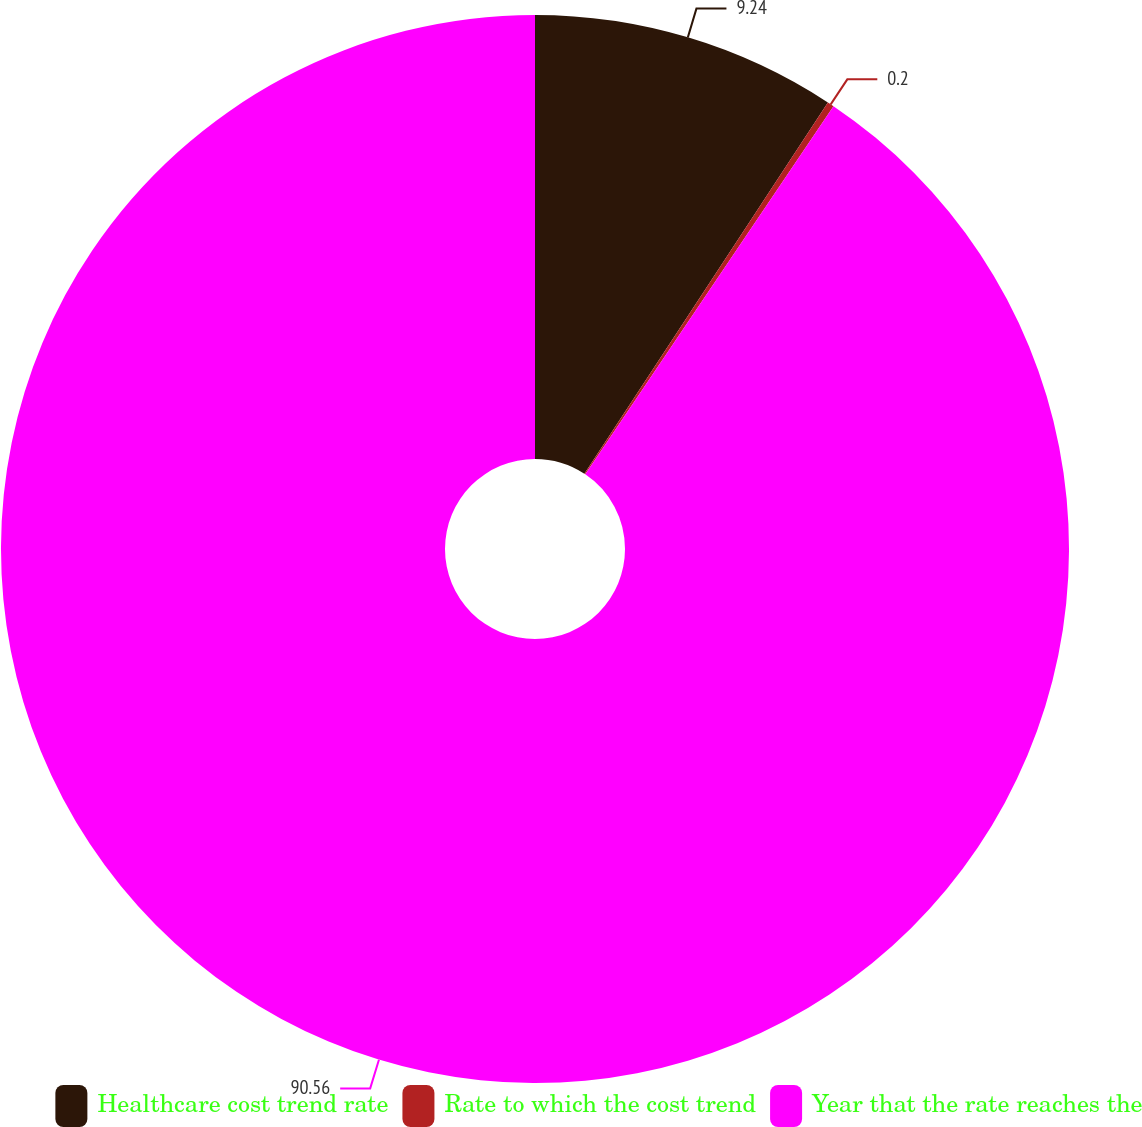Convert chart to OTSL. <chart><loc_0><loc_0><loc_500><loc_500><pie_chart><fcel>Healthcare cost trend rate<fcel>Rate to which the cost trend<fcel>Year that the rate reaches the<nl><fcel>9.24%<fcel>0.2%<fcel>90.56%<nl></chart> 